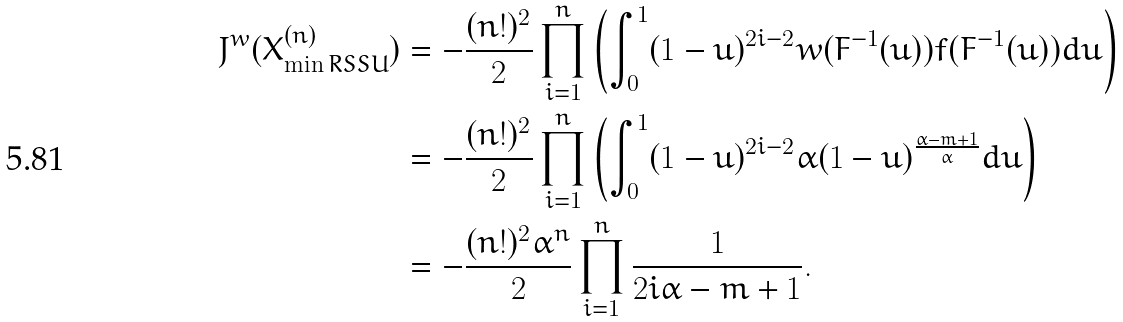<formula> <loc_0><loc_0><loc_500><loc_500>J ^ { w } ( X _ { \min R S S U } ^ { ( n ) } ) & = - \frac { ( n ! ) ^ { 2 } } { 2 } \prod _ { i = 1 } ^ { n } \left ( \int _ { 0 } ^ { 1 } ( 1 - u ) ^ { 2 i - 2 } w ( F ^ { - 1 } ( u ) ) f ( F ^ { - 1 } ( u ) ) d u \right ) \\ & = - \frac { ( n ! ) ^ { 2 } } { 2 } \prod _ { i = 1 } ^ { n } \left ( \int _ { 0 } ^ { 1 } ( 1 - u ) ^ { 2 i - 2 } \alpha ( 1 - u ) ^ { \frac { \alpha - m + 1 } { \alpha } } d u \right ) \\ & = - \frac { ( n ! ) ^ { 2 } \alpha ^ { n } } { 2 } \prod _ { i = 1 } ^ { n } \frac { 1 } { 2 i \alpha - m + 1 } .</formula> 